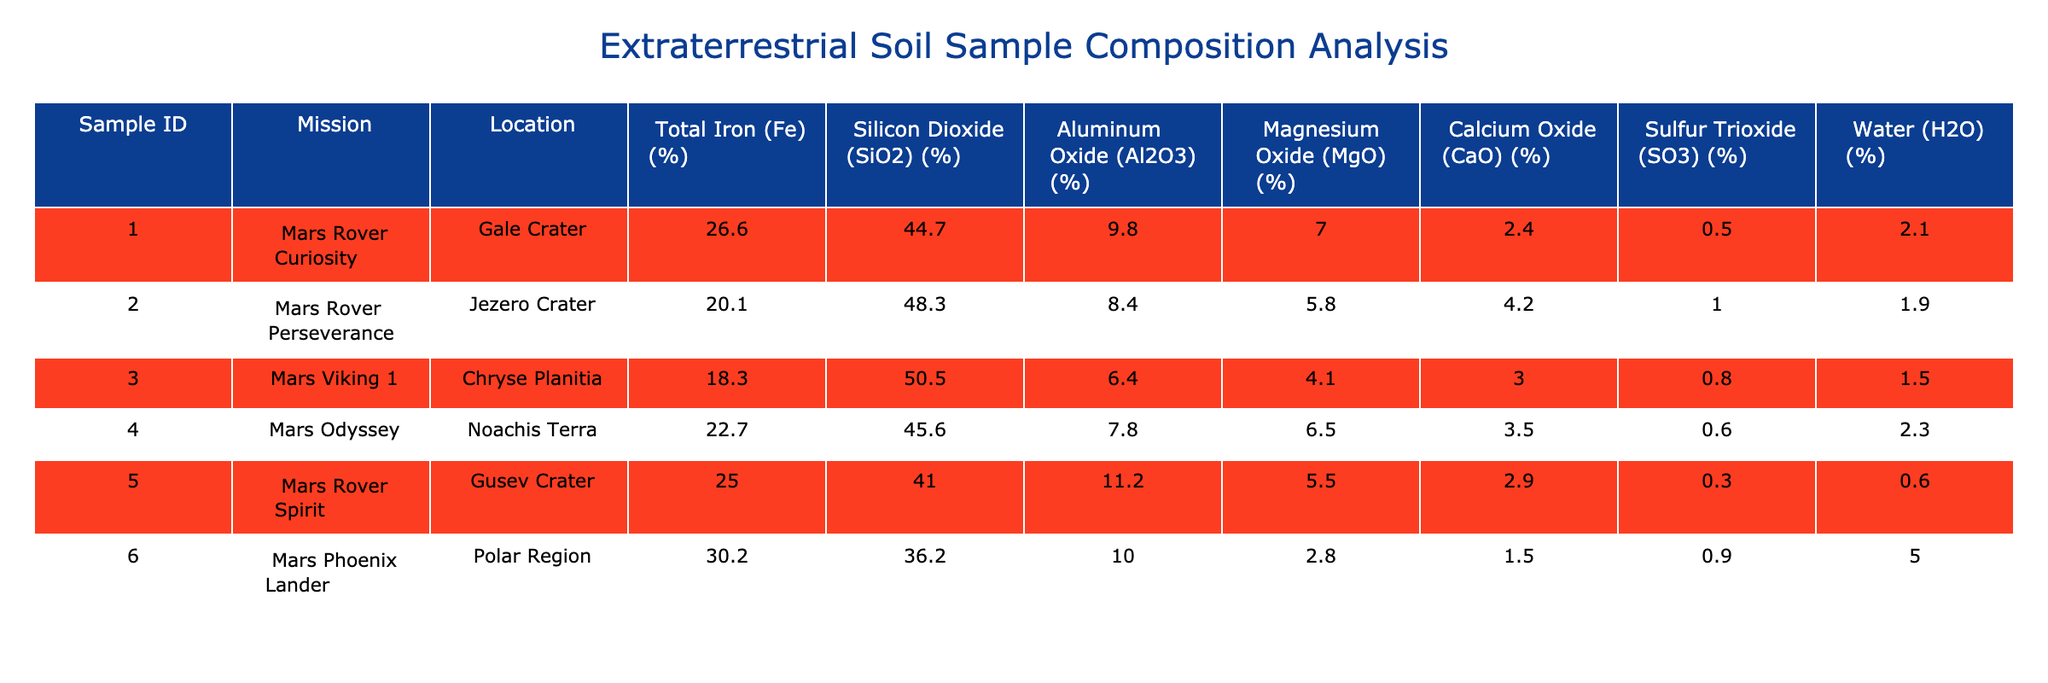What is the Total Iron content in the sample from Gale Crater? The table lists the Total Iron content for each sample, and for Gale Crater (Sample ID 1), the value is 26.6%.
Answer: 26.6% Which sample has the highest Silicon Dioxide percentage? By checking the Silicon Dioxide values for each sample, the maximum is found in Sample ID 2 (Jezero Crater) with 48.3%.
Answer: 48.3% Is the Total Iron content in Jezero Crater greater than that in Gale Crater? Comparing both values: Jezero Crater has 20.1% while Gale Crater has 26.6%, so 20.1% is not greater than 26.6%.
Answer: No What is the average Magnesium Oxide content of the samples? To calculate the average: (7.0 + 5.8 + 4.1 + 6.5 + 5.5 + 2.8) = 31.7, then divide by 6 samples: 31.7 / 6 = 5.28%.
Answer: 5.28% Which location has the highest content of Calcium Oxide? By examining the Calcium Oxide percentages, the sample from Jezero Crater (4.2% for Sample ID 2) has the highest value compared to others.
Answer: 4.2% What is the difference in Water content between the sample from Gale Crater and the sample from the Polar Region? The Water content from Gale Crater is 2.1% and from the Polar Region is 5.0%. The difference is 5.0% - 2.1% = 2.9%.
Answer: 2.9% Are there samples with the same Aluminum Oxide content? Reviewing the Aluminum Oxide values, none of the samples share the same percentage. Each sample has a unique value.
Answer: No What is the total percentage of Sulfur Trioxide across all samples? Sum the values: 0.5 + 1.0 + 0.8 + 0.6 + 0.3 + 0.9 = 3.1%.
Answer: 3.1% 